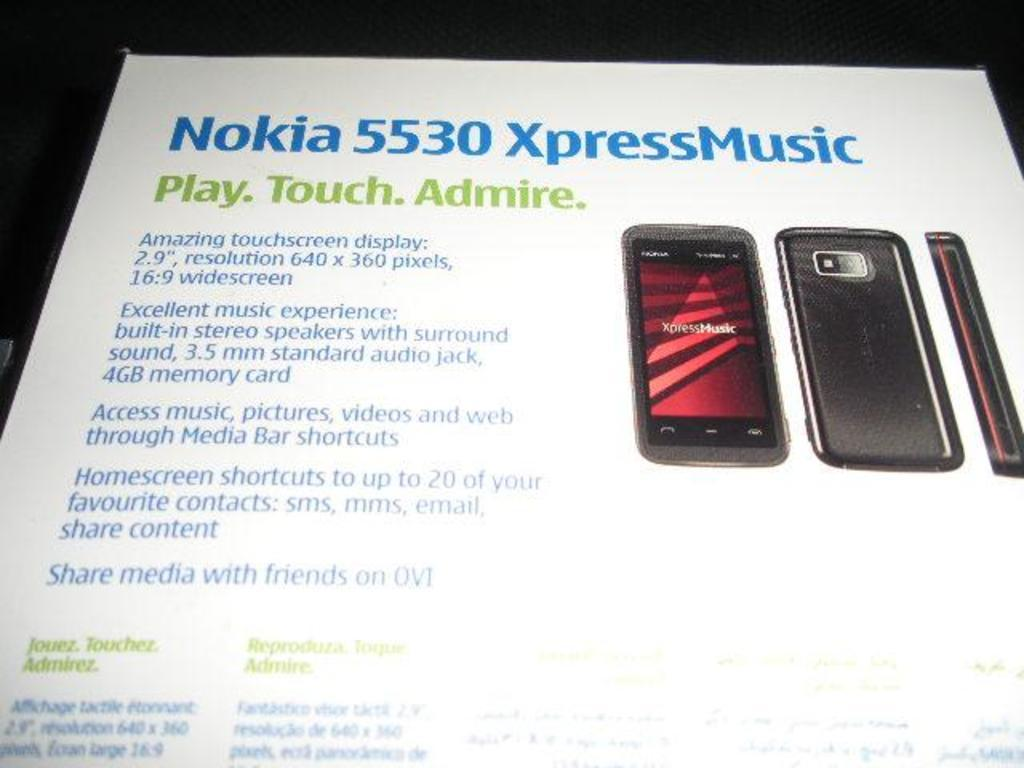Provide a one-sentence caption for the provided image. A Pumphelet of Nokia 5530 Xpress Music brand shows details. 